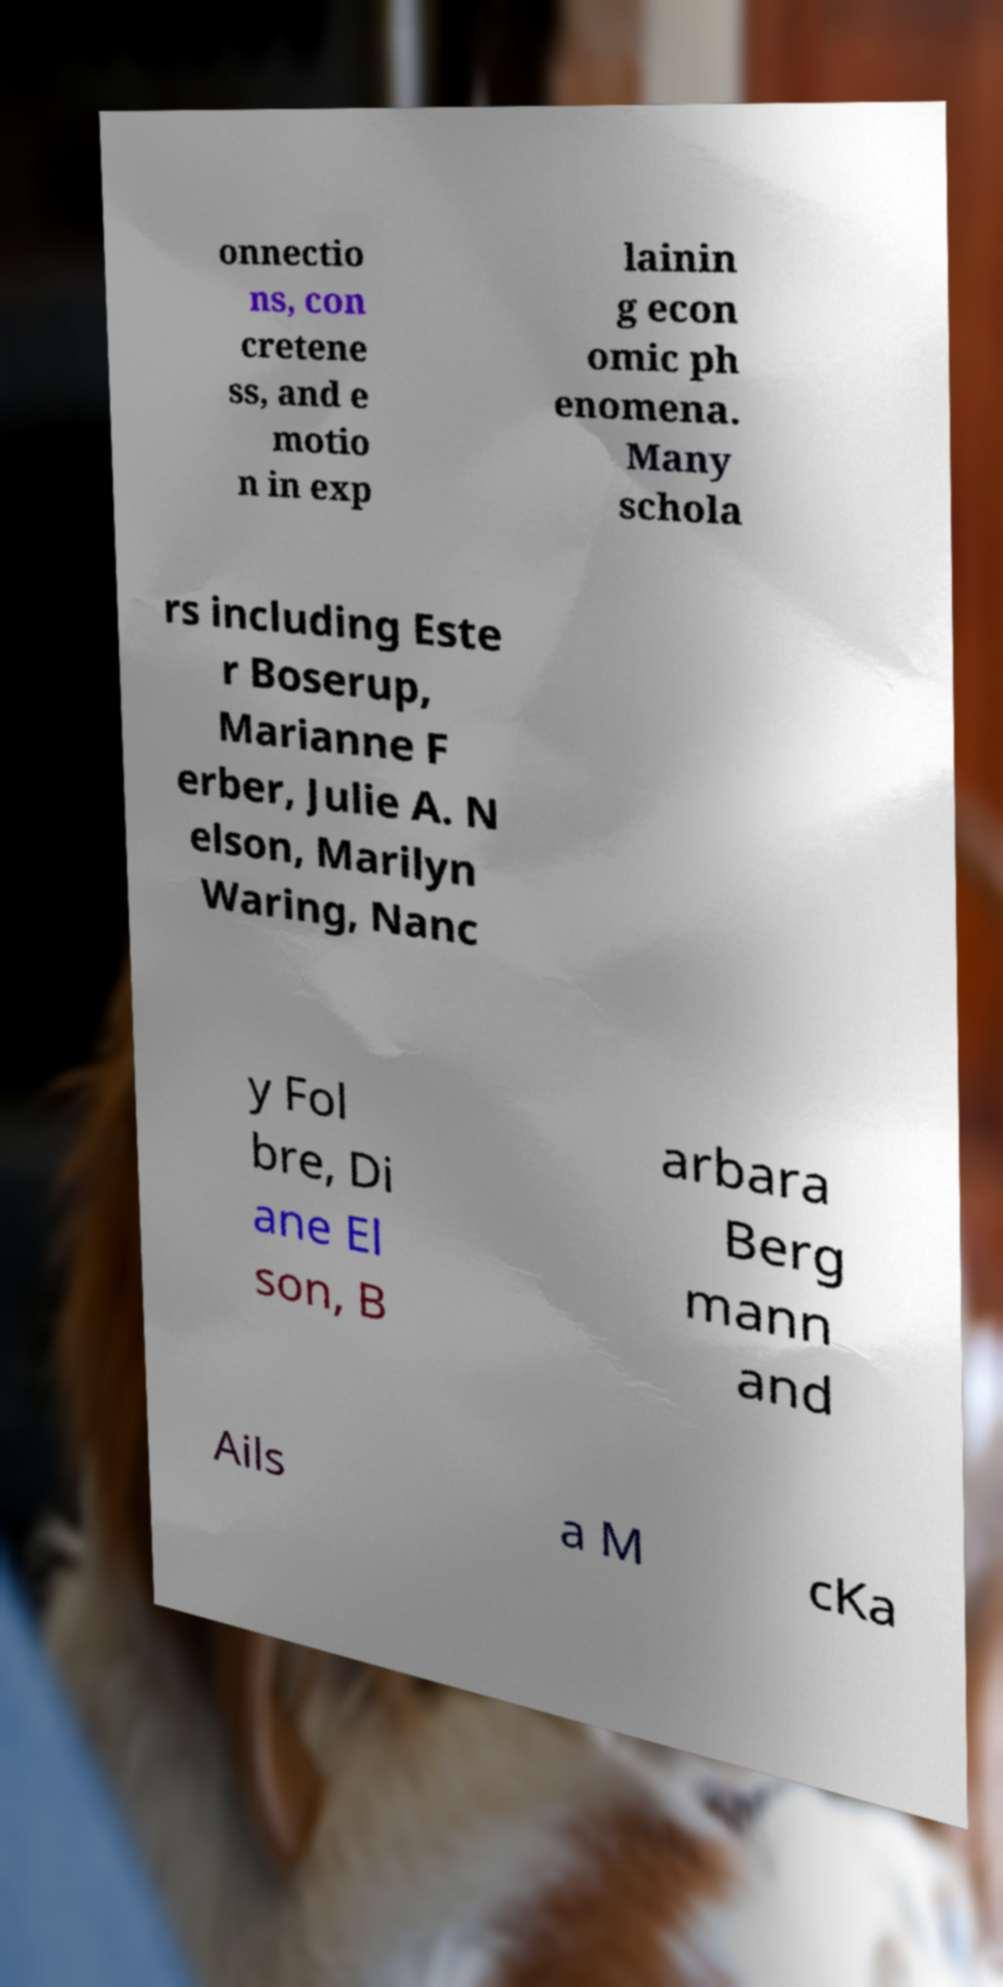Could you assist in decoding the text presented in this image and type it out clearly? onnectio ns, con cretene ss, and e motio n in exp lainin g econ omic ph enomena. Many schola rs including Este r Boserup, Marianne F erber, Julie A. N elson, Marilyn Waring, Nanc y Fol bre, Di ane El son, B arbara Berg mann and Ails a M cKa 